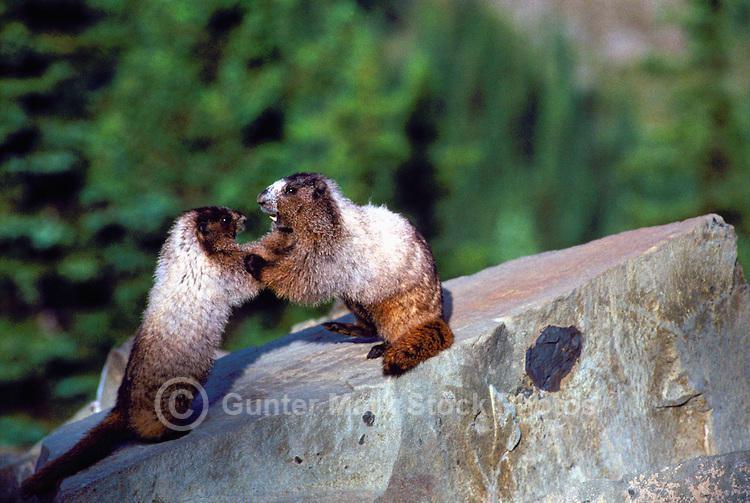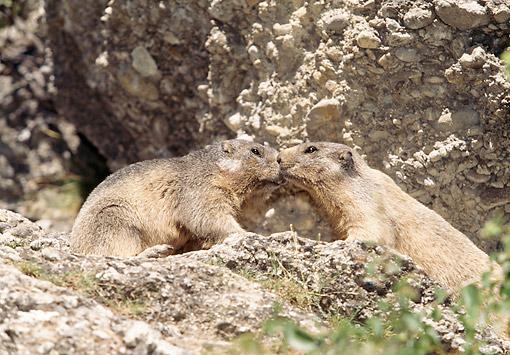The first image is the image on the left, the second image is the image on the right. For the images shown, is this caption "The left image contains exactly one rodent standing on grass." true? Answer yes or no. No. The first image is the image on the left, the second image is the image on the right. For the images displayed, is the sentence "An image contains one marmot, which stands upright in green grass with its body turned to the camera." factually correct? Answer yes or no. No. 